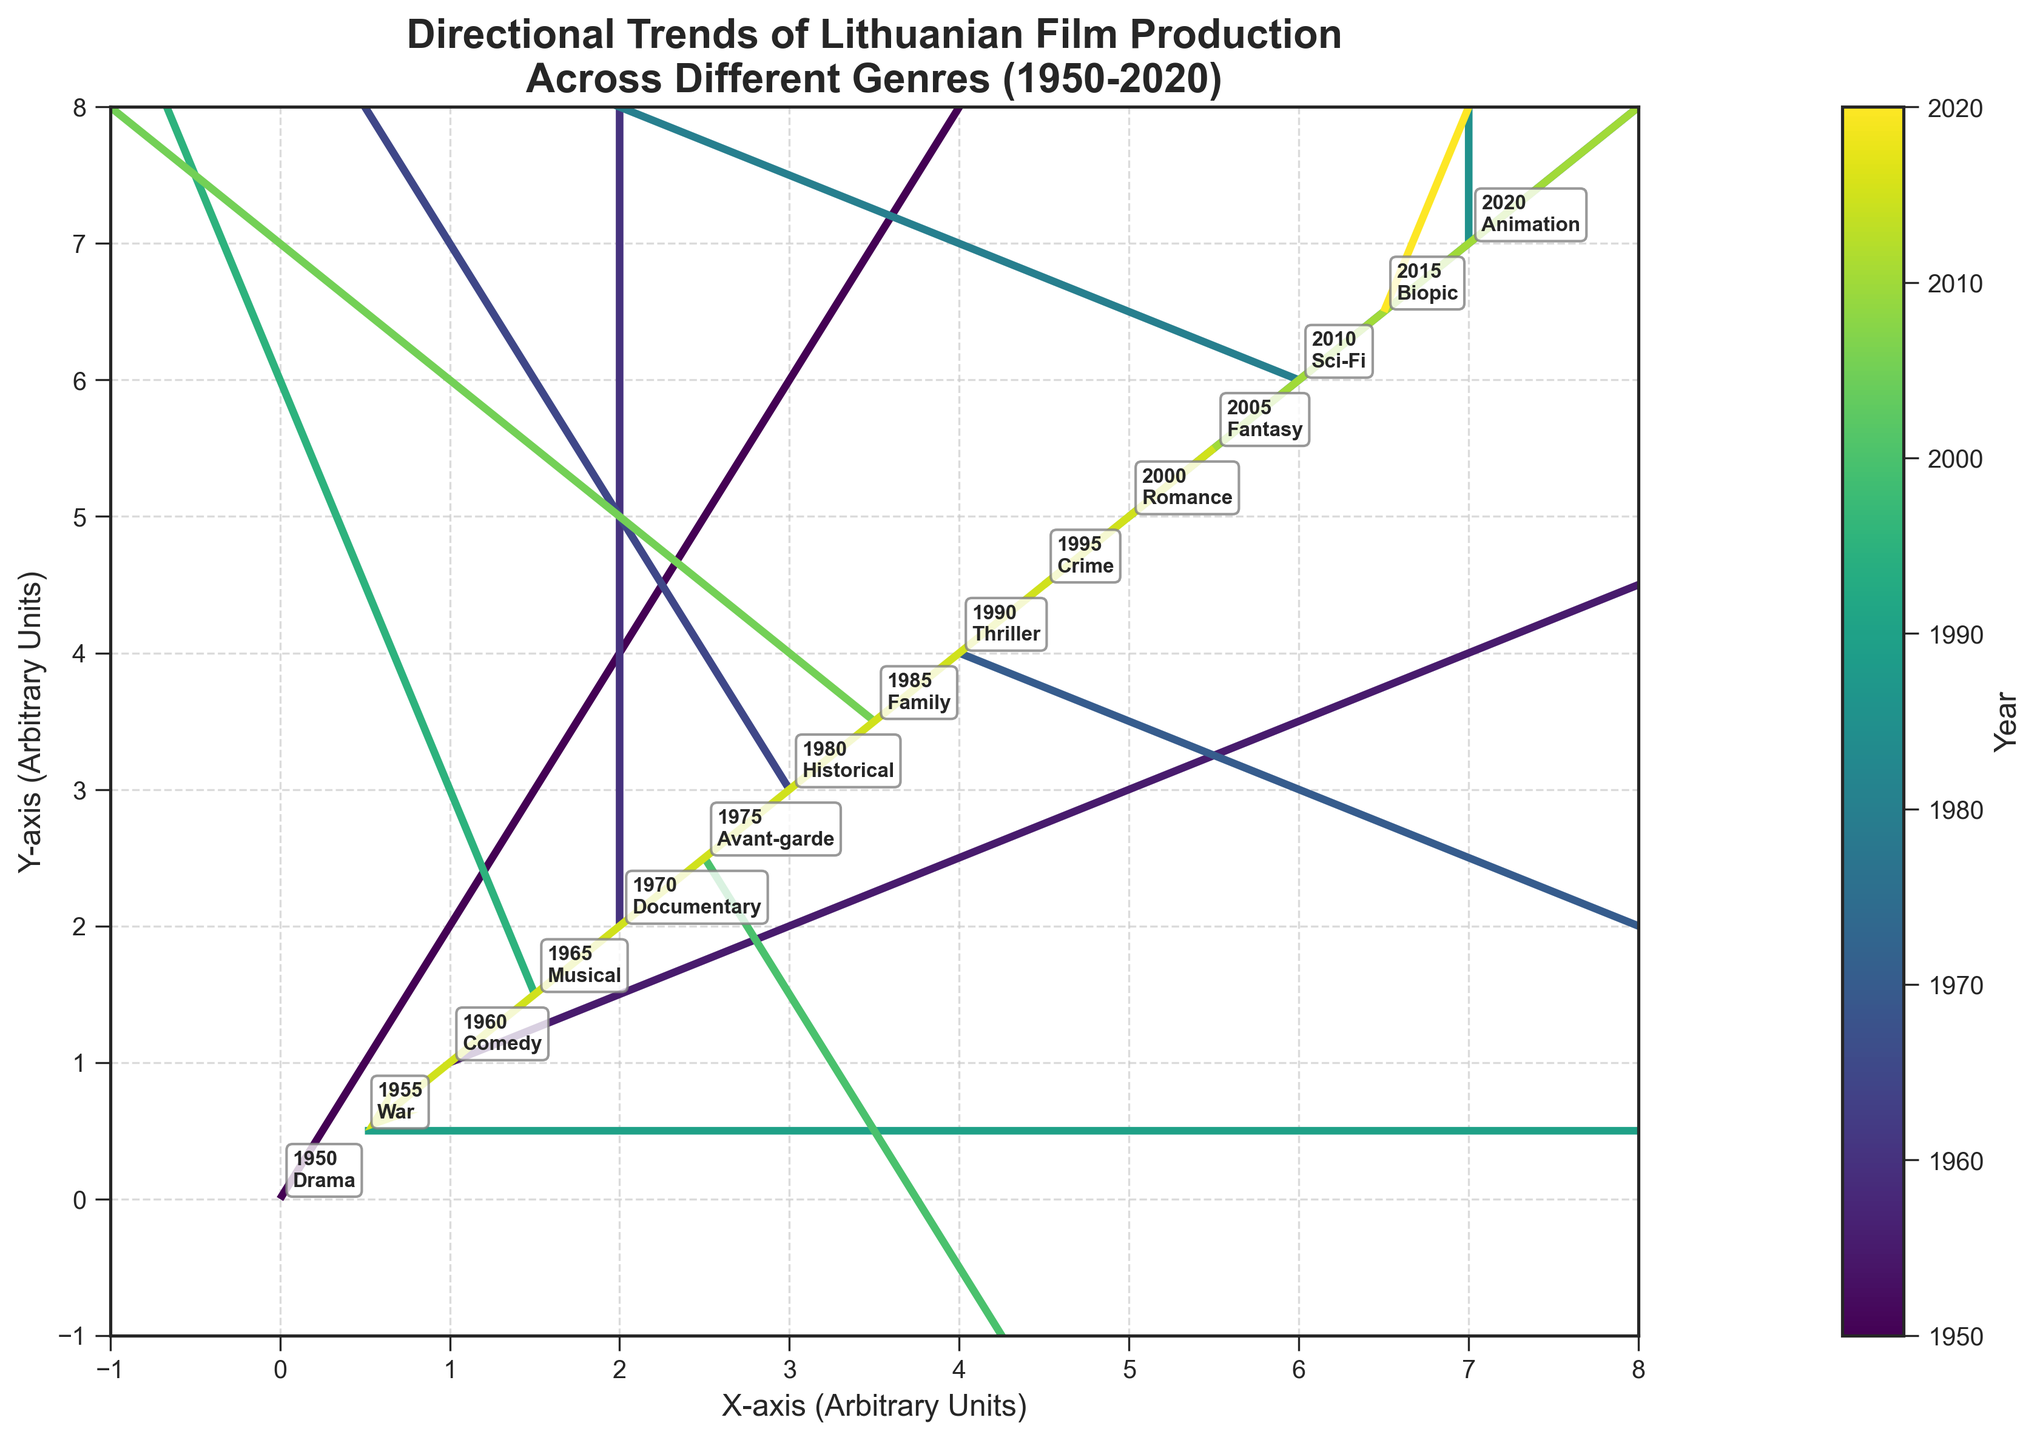What is the title of the plot? The title of the plot is shown at the top of the figure. It says "Directional Trends of Lithuanian Film Production Across Different Genres (1950-2020)"
Answer: Directional Trends of Lithuanian Film Production Across Different Genres (1950-2020) How many data points are shown in the plot? The number of data points can be counted based on the different labels visible on the figure. We see various genres and years labeled, and after counting, there are 15 data points.
Answer: 15 Which genre has a vector with the largest horizontal component? To find the vector with the largest horizontal component, we need to look at the 'U' values. The genre "War" from 1955 has a 'U' value of 3, which is the highest horizontal component.
Answer: War What is the direction of the vector representing 'Animation' in 2020? Look at the vector starting from the coordinates (7, 7) for 'Animation'. The vector's components are (0, 2), meaning it has no horizontal shift and points upwards vertically by 2 units.
Answer: Upwards Which decade has the most vertically positive trend overall? To answer this, we need to inspect the vertical components 'V' for each decade. The 1960s (including 1960, 1965), shows vectors with vertical components of 1 and 3, so the overall trend appears to be positive.
Answer: 1960s Which genre has a negative horizontal and positive vertical component and what's its direction? By examining the vectors, we find 'Family' from 1985 has a negative horizontal component (-2) and a positive vertical component (2), resulting in a vector pointing left and upwards.
Answer: Family; left and upwards Compare the trend of 'Thriller' in 1990 to 'Documentary' in 1970. Which one shows more upward movement? 'Thriller' in 1990 shows a vector with a vertical component -1 (downward), while 'Documentary' in 1970 shows a vector with a vertical component 3 (upward). Therefore, 'Documentary' shows more upward movement.
Answer: Documentary Which genre trend is pointing completely horizontally to the right? We look for a vector with a vertical component (V) of 0 and a positive horizontal component (U). 'War' in 1955 points completely horizontally to the right with the vector (3, 0).
Answer: War How does the trend of 'Fantasy' in 2005 compare to 'Romance' in 2000 in terms of direction? 'Fantasy' has the components (-1, -1) indicating a downward-left trend, while 'Romance' has the components (1, 1) indicating an upward-right trend.
Answer: Fantasy: downward-left, Romance: upward-right 